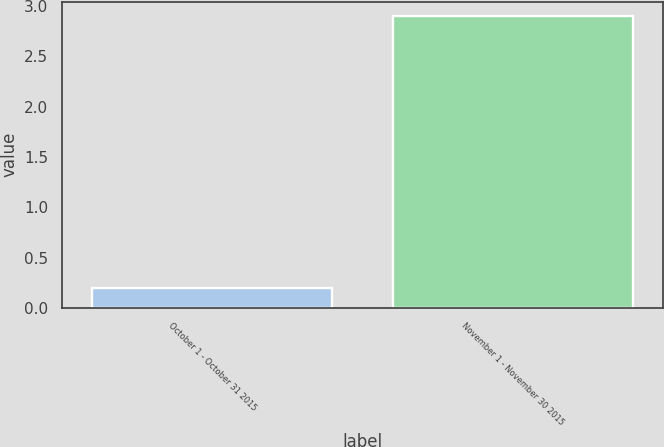Convert chart. <chart><loc_0><loc_0><loc_500><loc_500><bar_chart><fcel>October 1 - October 31 2015<fcel>November 1 - November 30 2015<nl><fcel>0.2<fcel>2.9<nl></chart> 